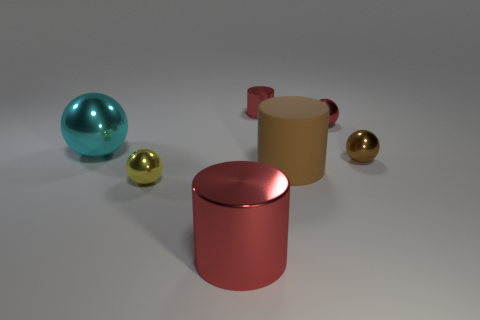There is a large object on the right side of the red cylinder to the right of the large object that is in front of the yellow object; what is its material?
Keep it short and to the point. Rubber. How many other objects are the same size as the red sphere?
Provide a succinct answer. 3. The large metallic cylinder is what color?
Ensure brevity in your answer.  Red. How many metallic objects are either big gray cylinders or spheres?
Keep it short and to the point. 4. Is there anything else that has the same material as the small yellow sphere?
Your answer should be compact. Yes. There is a metallic cylinder in front of the shiny cylinder that is behind the red metal cylinder that is in front of the small yellow ball; how big is it?
Your response must be concise. Large. There is a red object that is to the left of the brown cylinder and behind the yellow sphere; how big is it?
Provide a short and direct response. Small. There is a shiny cylinder in front of the cyan metal ball; does it have the same color as the metal ball on the left side of the small yellow sphere?
Your answer should be compact. No. How many tiny brown metallic objects are to the left of the brown rubber object?
Your answer should be very brief. 0. Are there any brown spheres left of the small brown metallic ball on the right side of the big object behind the big matte cylinder?
Ensure brevity in your answer.  No. 